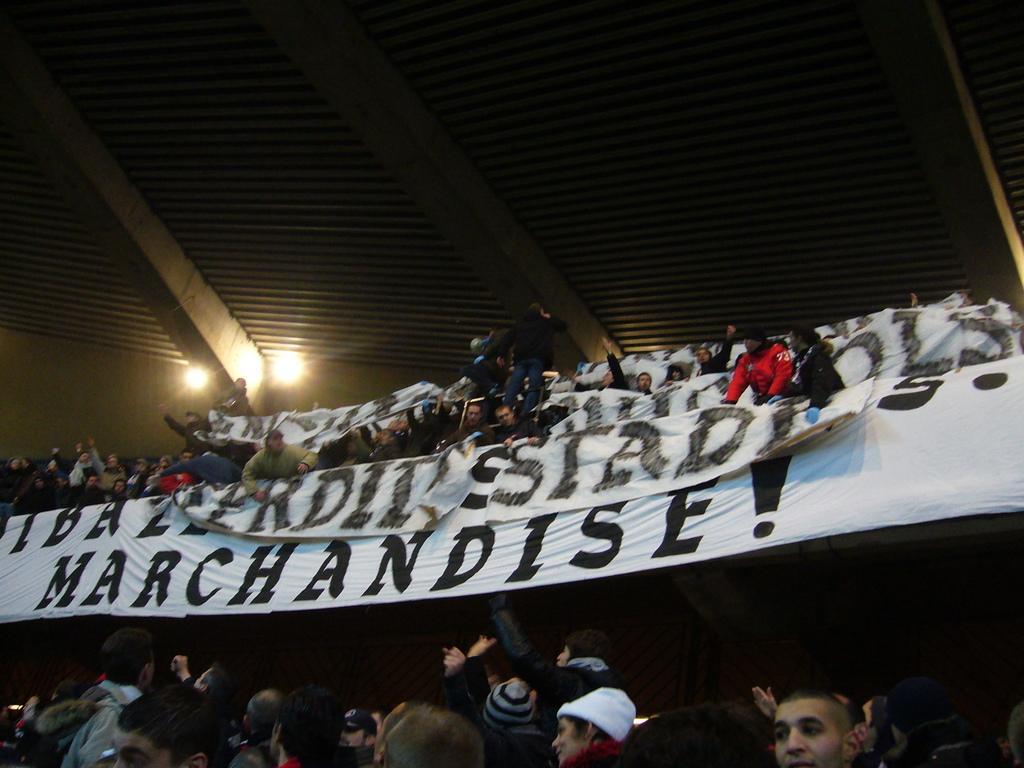How would you summarize this image in a sentence or two? In the image there is a huge crowd and some banners, there is a roof above the crowd. 